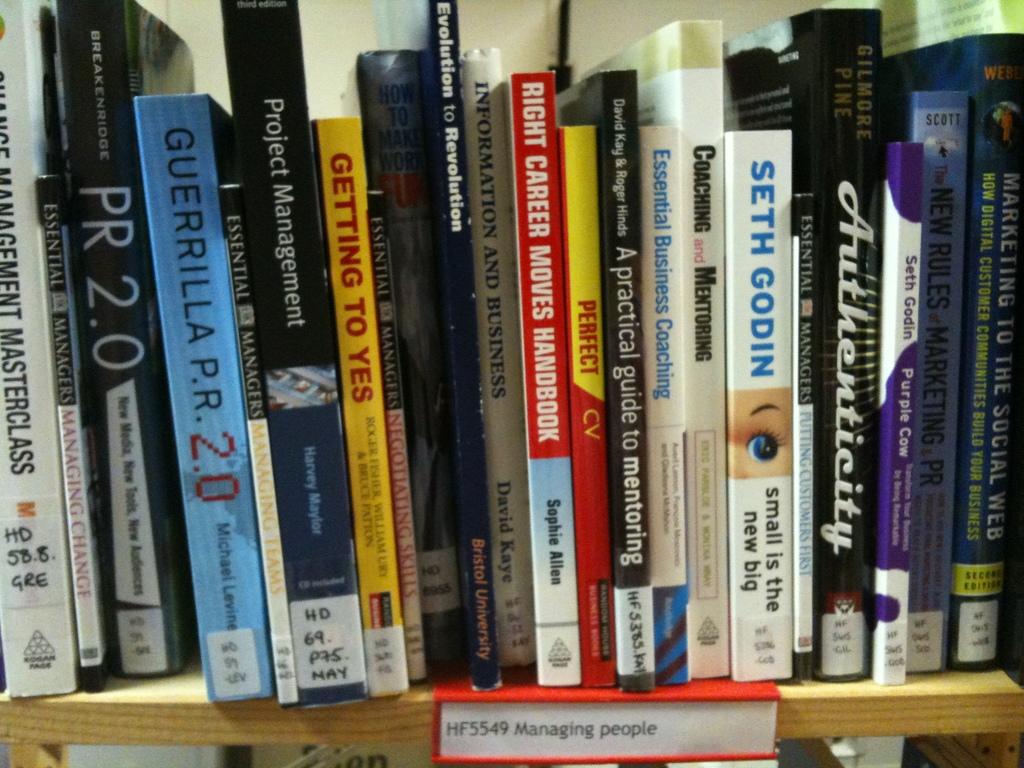What is the first name of the author, godin, on one of the books?
Offer a terse response. Seth. Who wrote the right career moves handbook?
Ensure brevity in your answer.  Sophie allen. 